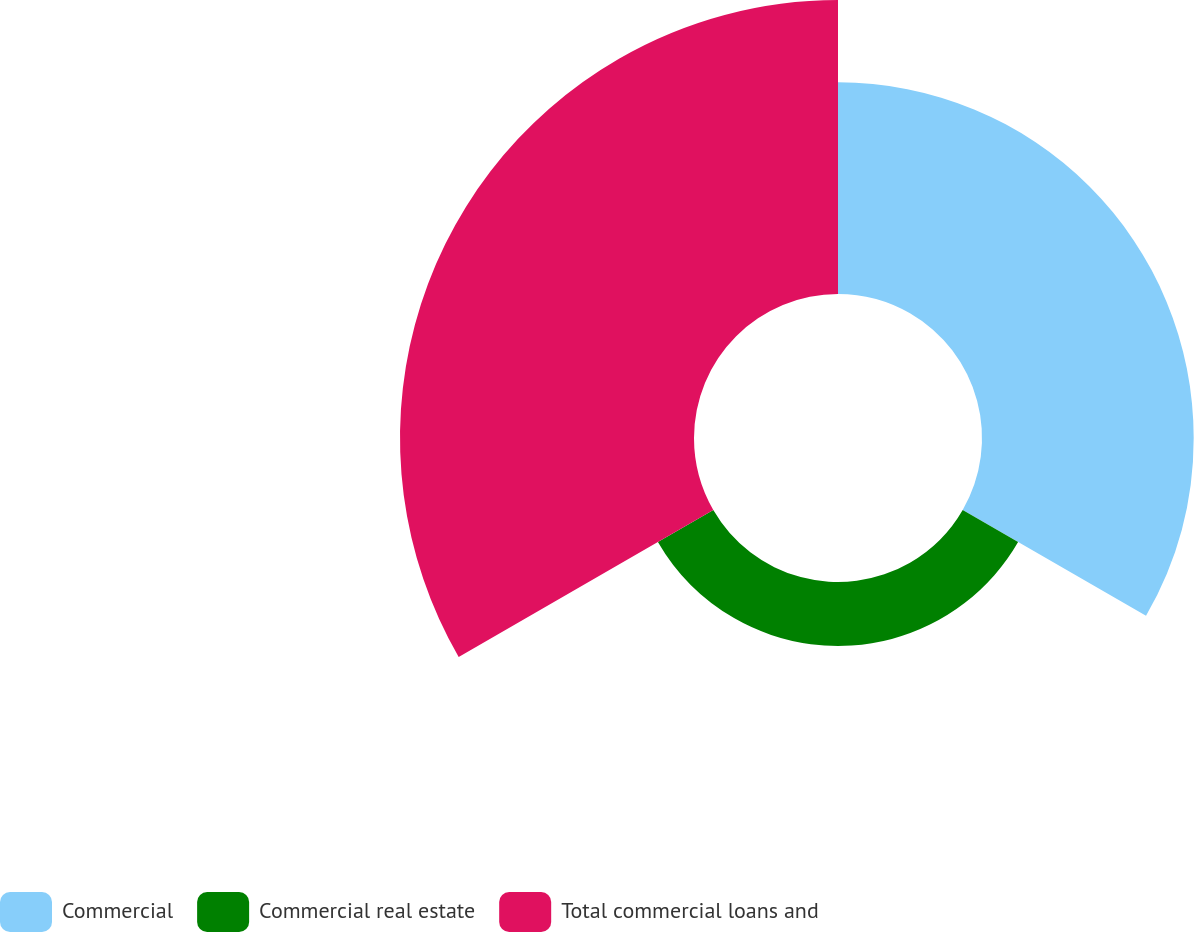Convert chart. <chart><loc_0><loc_0><loc_500><loc_500><pie_chart><fcel>Commercial<fcel>Commercial real estate<fcel>Total commercial loans and<nl><fcel>37.16%<fcel>11.23%<fcel>51.61%<nl></chart> 